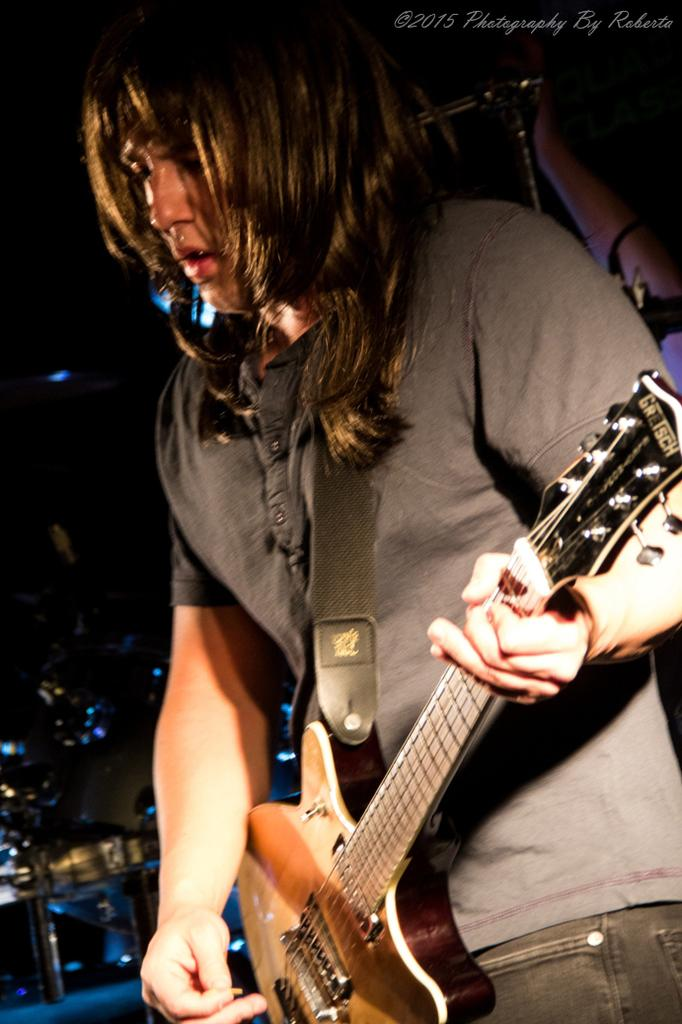What is the main subject of the image? There is a man in the image. What is the man doing in the image? The man is standing in the image. What object is the man holding in the image? The man is holding a guitar in the image. What type of tooth can be seen in the image? There is no tooth present in the image. Is the man playing the guitar in a stream in the image? There is no stream present in the image, and the man is not playing the guitar; he is simply holding it. 